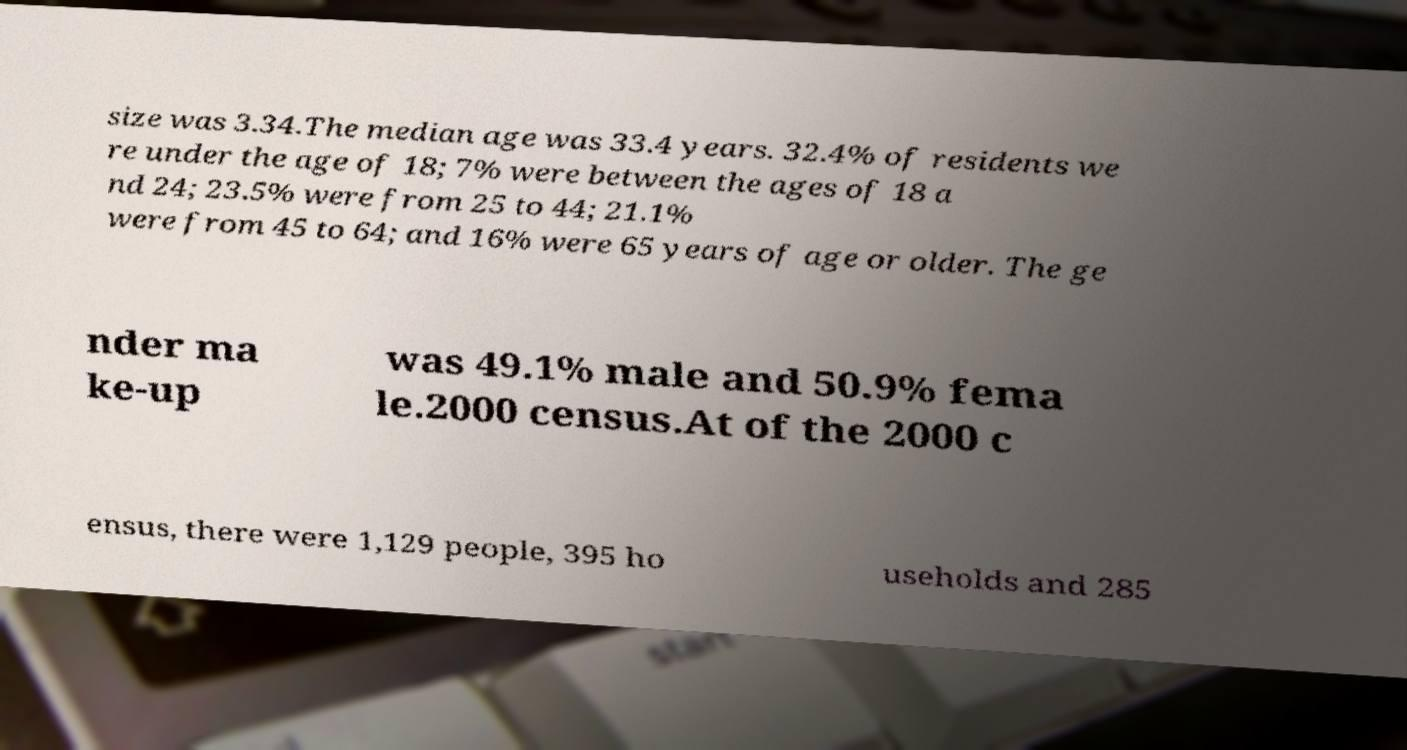What messages or text are displayed in this image? I need them in a readable, typed format. size was 3.34.The median age was 33.4 years. 32.4% of residents we re under the age of 18; 7% were between the ages of 18 a nd 24; 23.5% were from 25 to 44; 21.1% were from 45 to 64; and 16% were 65 years of age or older. The ge nder ma ke-up was 49.1% male and 50.9% fema le.2000 census.At of the 2000 c ensus, there were 1,129 people, 395 ho useholds and 285 